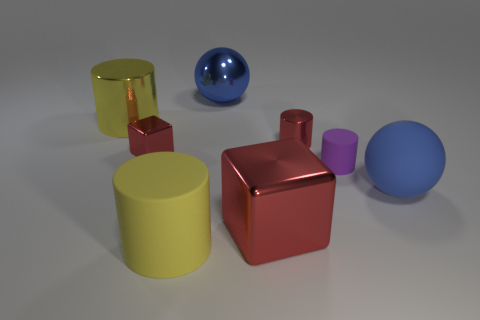Is there anything else that is the same shape as the purple thing?
Provide a succinct answer. Yes. What is the color of the large block that is the same material as the tiny red block?
Your response must be concise. Red. Is there a object that is left of the matte cylinder that is in front of the large ball on the right side of the blue metal ball?
Your response must be concise. Yes. Are there fewer tiny matte things on the left side of the big metallic cylinder than yellow matte objects that are left of the big yellow rubber cylinder?
Your response must be concise. No. What number of yellow cylinders have the same material as the red cylinder?
Provide a succinct answer. 1. There is a matte sphere; is it the same size as the matte cylinder that is behind the big blue rubber sphere?
Offer a terse response. No. There is a big thing that is the same color as the large metallic sphere; what is it made of?
Give a very brief answer. Rubber. There is a red object that is on the left side of the yellow cylinder in front of the large cylinder to the left of the big yellow matte cylinder; what size is it?
Your response must be concise. Small. Is the number of matte things that are to the right of the big cube greater than the number of red blocks that are in front of the large blue rubber thing?
Ensure brevity in your answer.  Yes. What number of yellow cylinders are on the left side of the matte cylinder to the left of the large shiny ball?
Give a very brief answer. 1. 